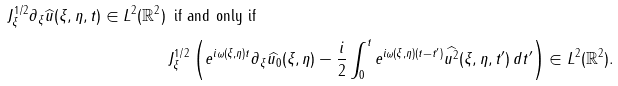Convert formula to latex. <formula><loc_0><loc_0><loc_500><loc_500>J ^ { 1 / 2 } _ { \xi } \partial _ { \xi } \widehat { u } ( \xi , \eta , t ) \in L ^ { 2 } ( \mathbb { R } ^ { 2 } ) \, & \text { if and only if } \, \\ & J _ { \xi } ^ { 1 / 2 } \left ( e ^ { i \omega ( \xi , \eta ) t } \partial _ { \xi } \widehat { u _ { 0 } } ( \xi , \eta ) - \frac { i } { 2 } \int _ { 0 } ^ { t } e ^ { i \omega ( \xi , \eta ) ( t - t ^ { \prime } ) } \widehat { u ^ { 2 } } ( \xi , \eta , t ^ { \prime } ) \, d t ^ { \prime } \right ) \in L ^ { 2 } ( \mathbb { R } ^ { 2 } ) .</formula> 